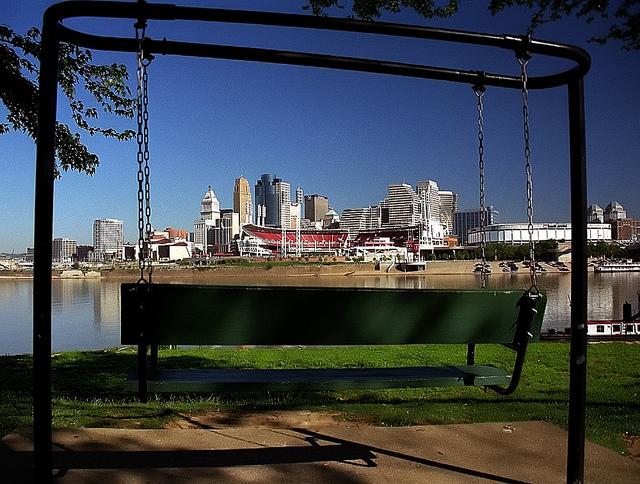What color is the swing?
Keep it brief. Green. How many people are on the swing?
Concise answer only. 0. What's in the background?
Be succinct. City. 